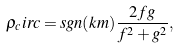<formula> <loc_0><loc_0><loc_500><loc_500>\rho _ { c } i r c = s g n ( k m ) \frac { 2 f g } { f ^ { 2 } + g ^ { 2 } } ,</formula> 